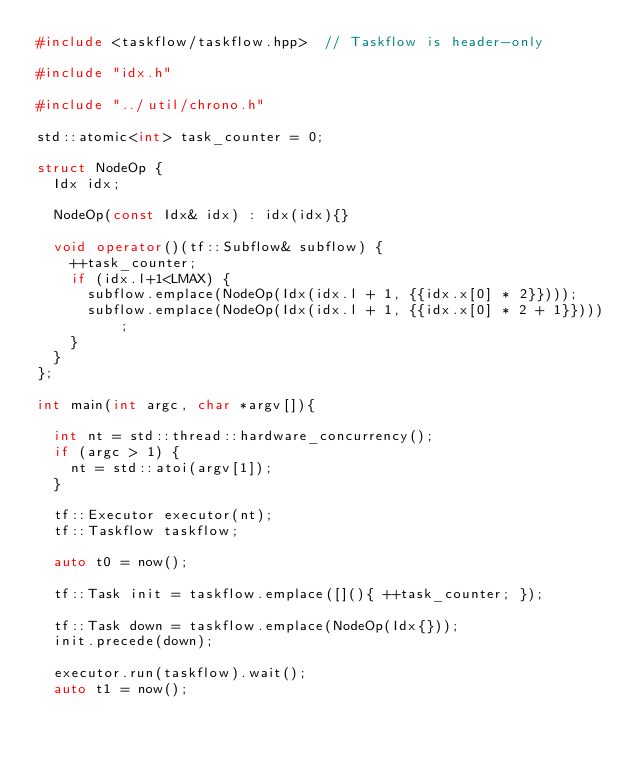<code> <loc_0><loc_0><loc_500><loc_500><_C++_>#include <taskflow/taskflow.hpp>  // Taskflow is header-only

#include "idx.h"

#include "../util/chrono.h"

std::atomic<int> task_counter = 0;

struct NodeOp {
  Idx idx;

  NodeOp(const Idx& idx) : idx(idx){}

  void operator()(tf::Subflow& subflow) {
    ++task_counter;
    if (idx.l+1<LMAX) {
      subflow.emplace(NodeOp(Idx(idx.l + 1, {{idx.x[0] * 2}})));
      subflow.emplace(NodeOp(Idx(idx.l + 1, {{idx.x[0] * 2 + 1}})));
    }
  }
};

int main(int argc, char *argv[]){

  int nt = std::thread::hardware_concurrency();
  if (argc > 1) {
    nt = std::atoi(argv[1]);
  }

  tf::Executor executor(nt);
  tf::Taskflow taskflow;

  auto t0 = now();

  tf::Task init = taskflow.emplace([](){ ++task_counter; });

  tf::Task down = taskflow.emplace(NodeOp(Idx{}));
  init.precede(down);

  executor.run(taskflow).wait();
  auto t1 = now();</code> 